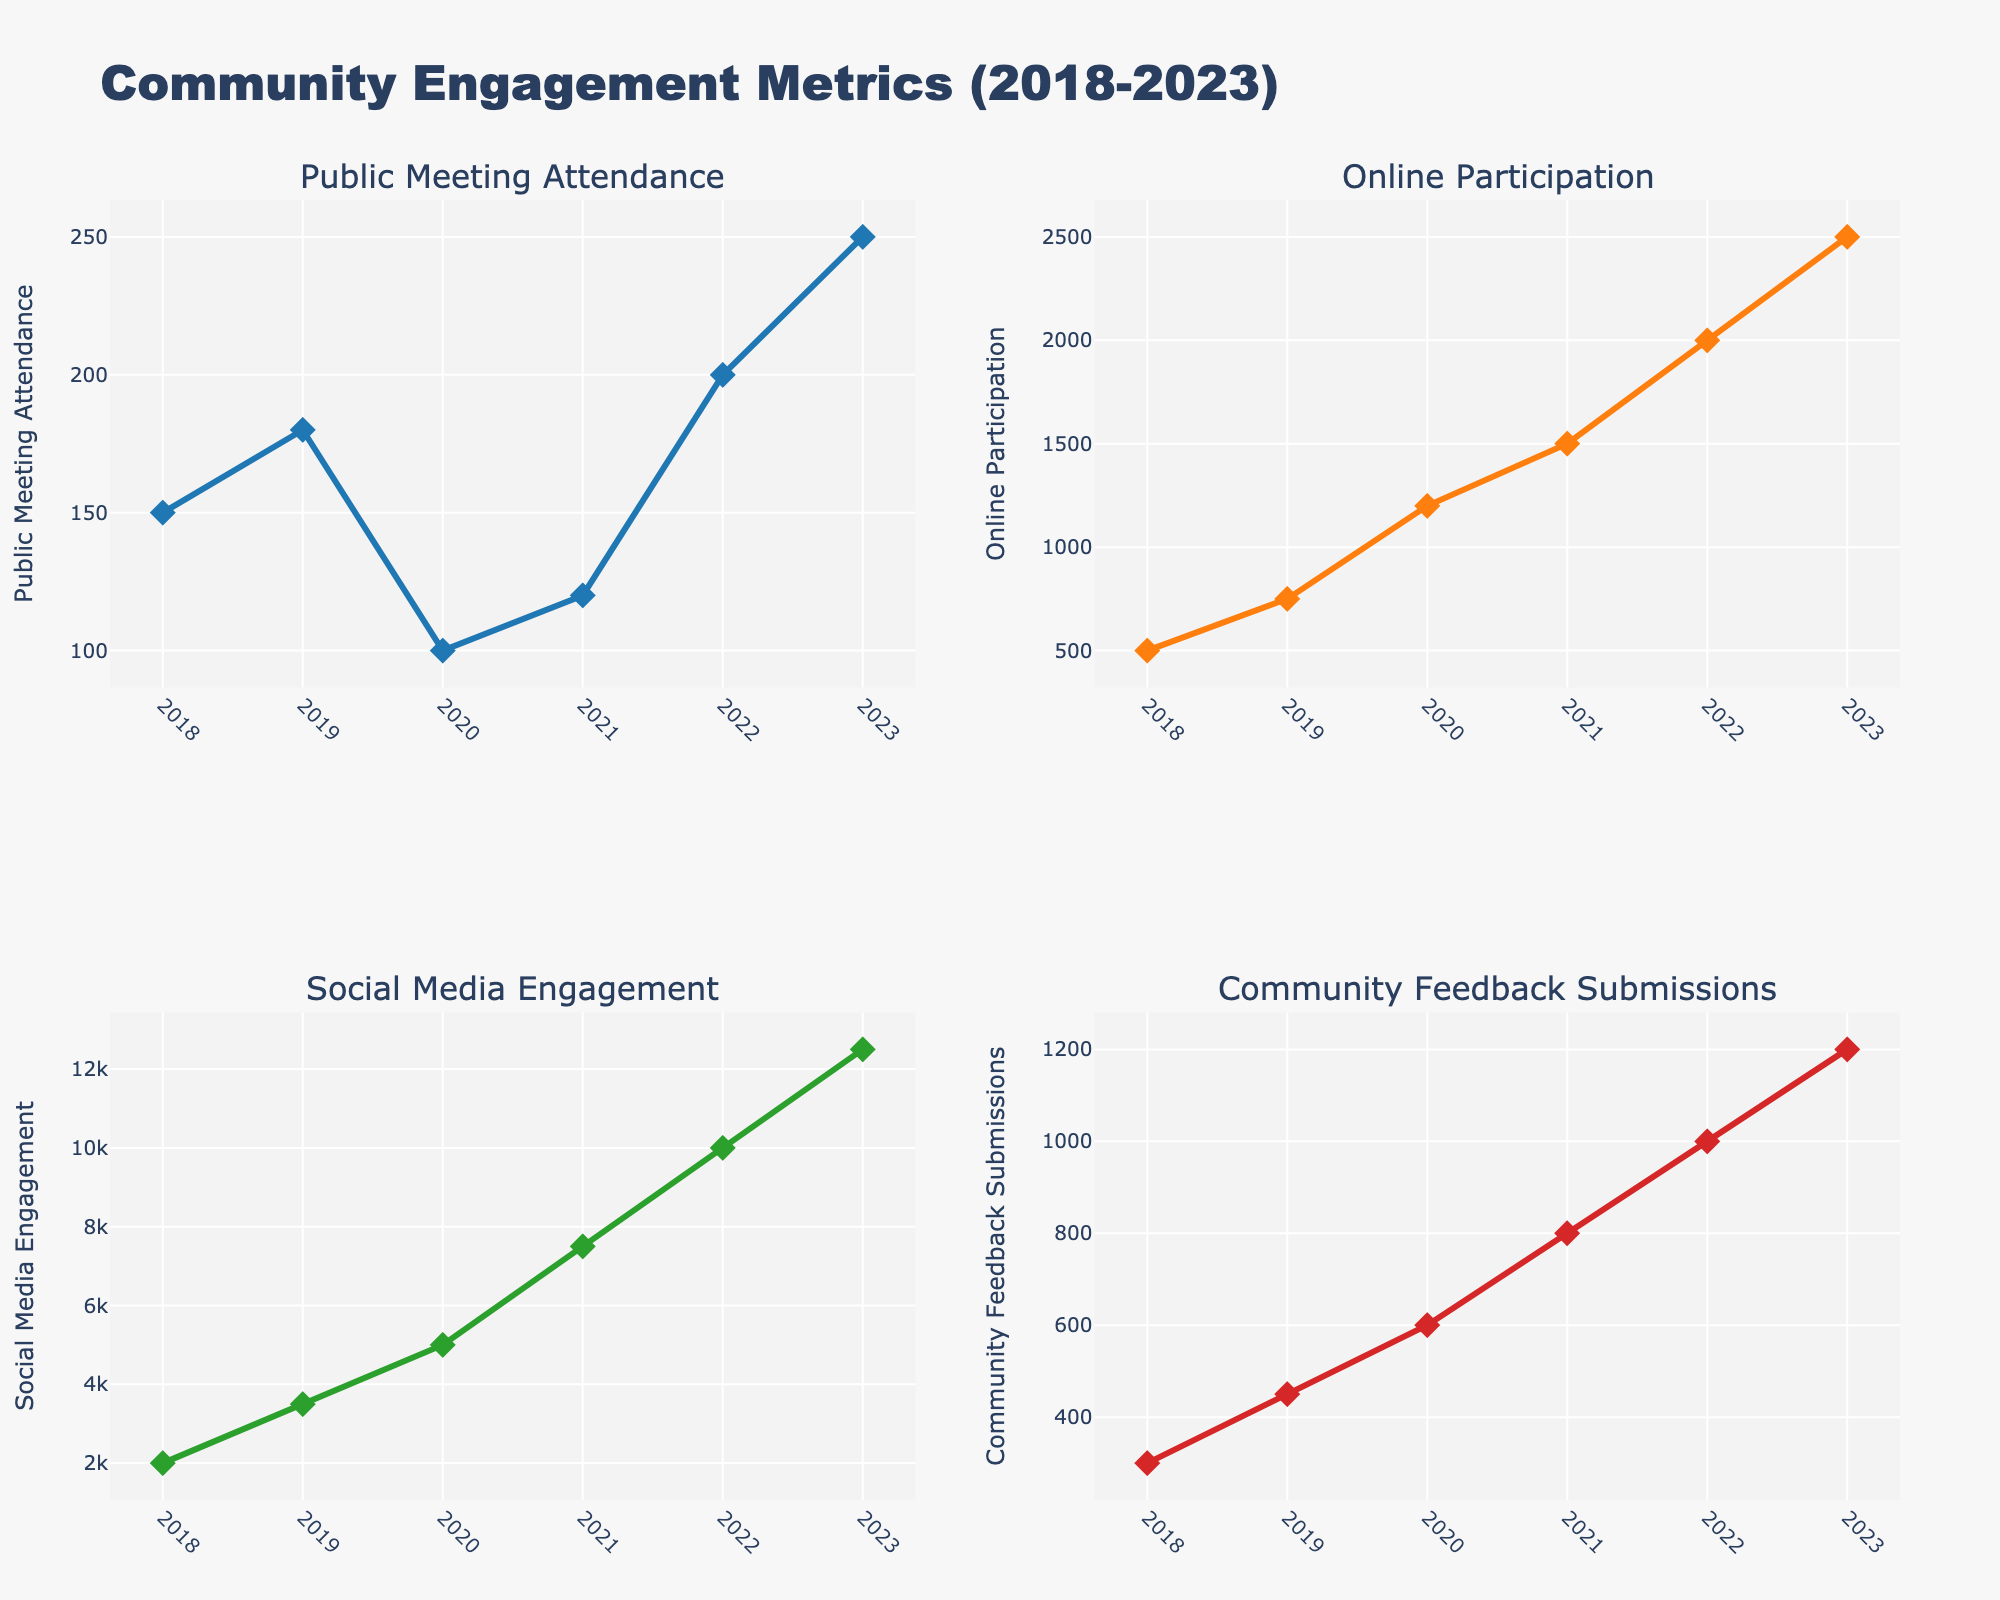What's the title of the figure? The title of the figure is usually located at the top center; in this specific figure, it reads "Community Engagement Metrics (2018-2023)"
Answer: Community Engagement Metrics (2018-2023) How many subplots are in the figure? The figure consists of a 2x2 grid, thus it contains 4 subplots in total
Answer: 4 What is the trend in Social Media Engagement from 2018 to 2023? To identify the trend, look at the "Social Media Engagement" subplot. Observe the line connecting the data points showing a continuous increase from 2000 in 2018 to 12500 in 2023. This indicates an upward trend over these years
Answer: Upward trend Which year had the highest Online Participation? By observing the "Online Participation" subplot, locate the highest point on the y-axis, which corresponds to 2023 with a value of 2500
Answer: 2023 Comparing 2018 and 2023, which metric had the largest increase in value? Calculate the increase for each metric: Public Meeting Attendance (250-150=100), Online Participation (2500-500=2000), Social Media Engagement (12500-2000=10500), Community Feedback Submissions (1200-300=900). The largest increase is for Social Media Engagement
Answer: Social Media Engagement What is the average Public Meeting Attendance over the years? Add up all the values for Public Meeting Attendance and divide by the number of years: (150 + 180 + 100 + 120 + 200 + 250) / 6 = 1000 / 6 ≈ 166.67
Answer: ≈ 166.67 Which metric showed a decline between any of the consecutive years? Analyze each subplot for decreases between consecutive years. "Public Meeting Attendance" declined from 180 (2019) to 100 (2020) and "Community Feedback Submissions" showed a steady increase
Answer: Public Meeting Attendance Between 2019 and 2021, how did the Community Feedback Submissions change? Look into the "Community Feedback Submissions" subplot. From 2019 to 2020, it increased from 450 to 600, and from 2020 to 2021, it further increased from 600 to 800
Answer: Increased How does the 2023 Community Feedback Submissions compare to that in 2020? Examine the "Community Feedback Submissions" subplot for the years 2020 and 2023, with values 600 and 1200 respectively, which shows that the 2023 value is twice as high as the 2020 value
Answer: Twice as high in 2023 